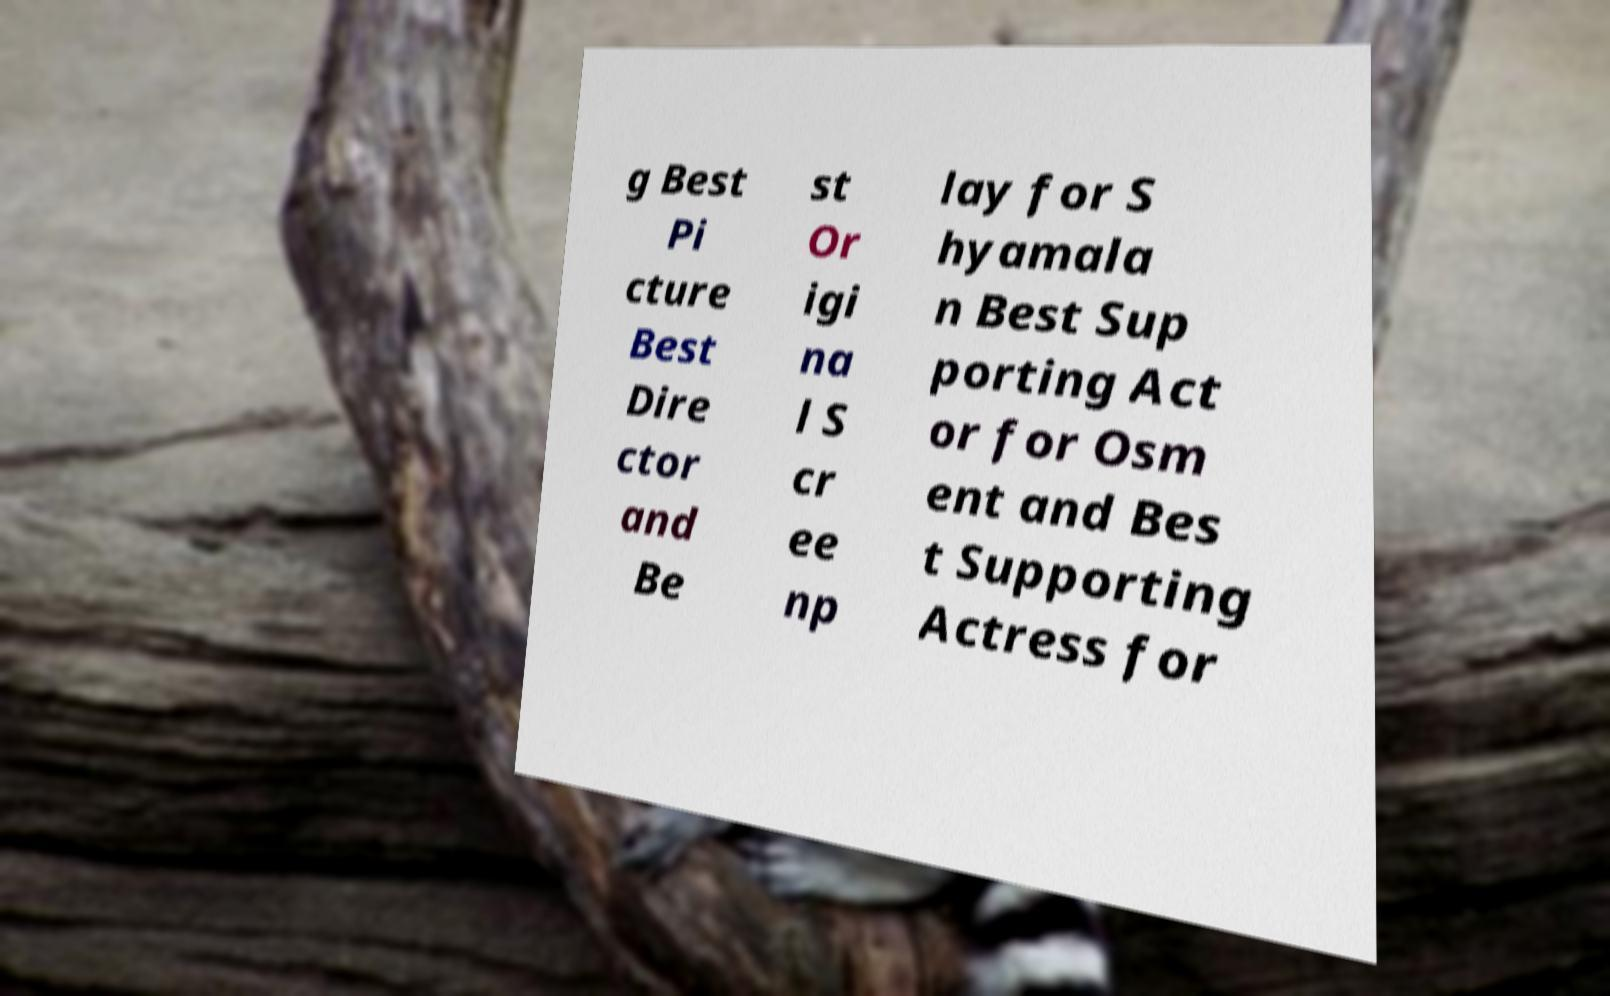What messages or text are displayed in this image? I need them in a readable, typed format. g Best Pi cture Best Dire ctor and Be st Or igi na l S cr ee np lay for S hyamala n Best Sup porting Act or for Osm ent and Bes t Supporting Actress for 